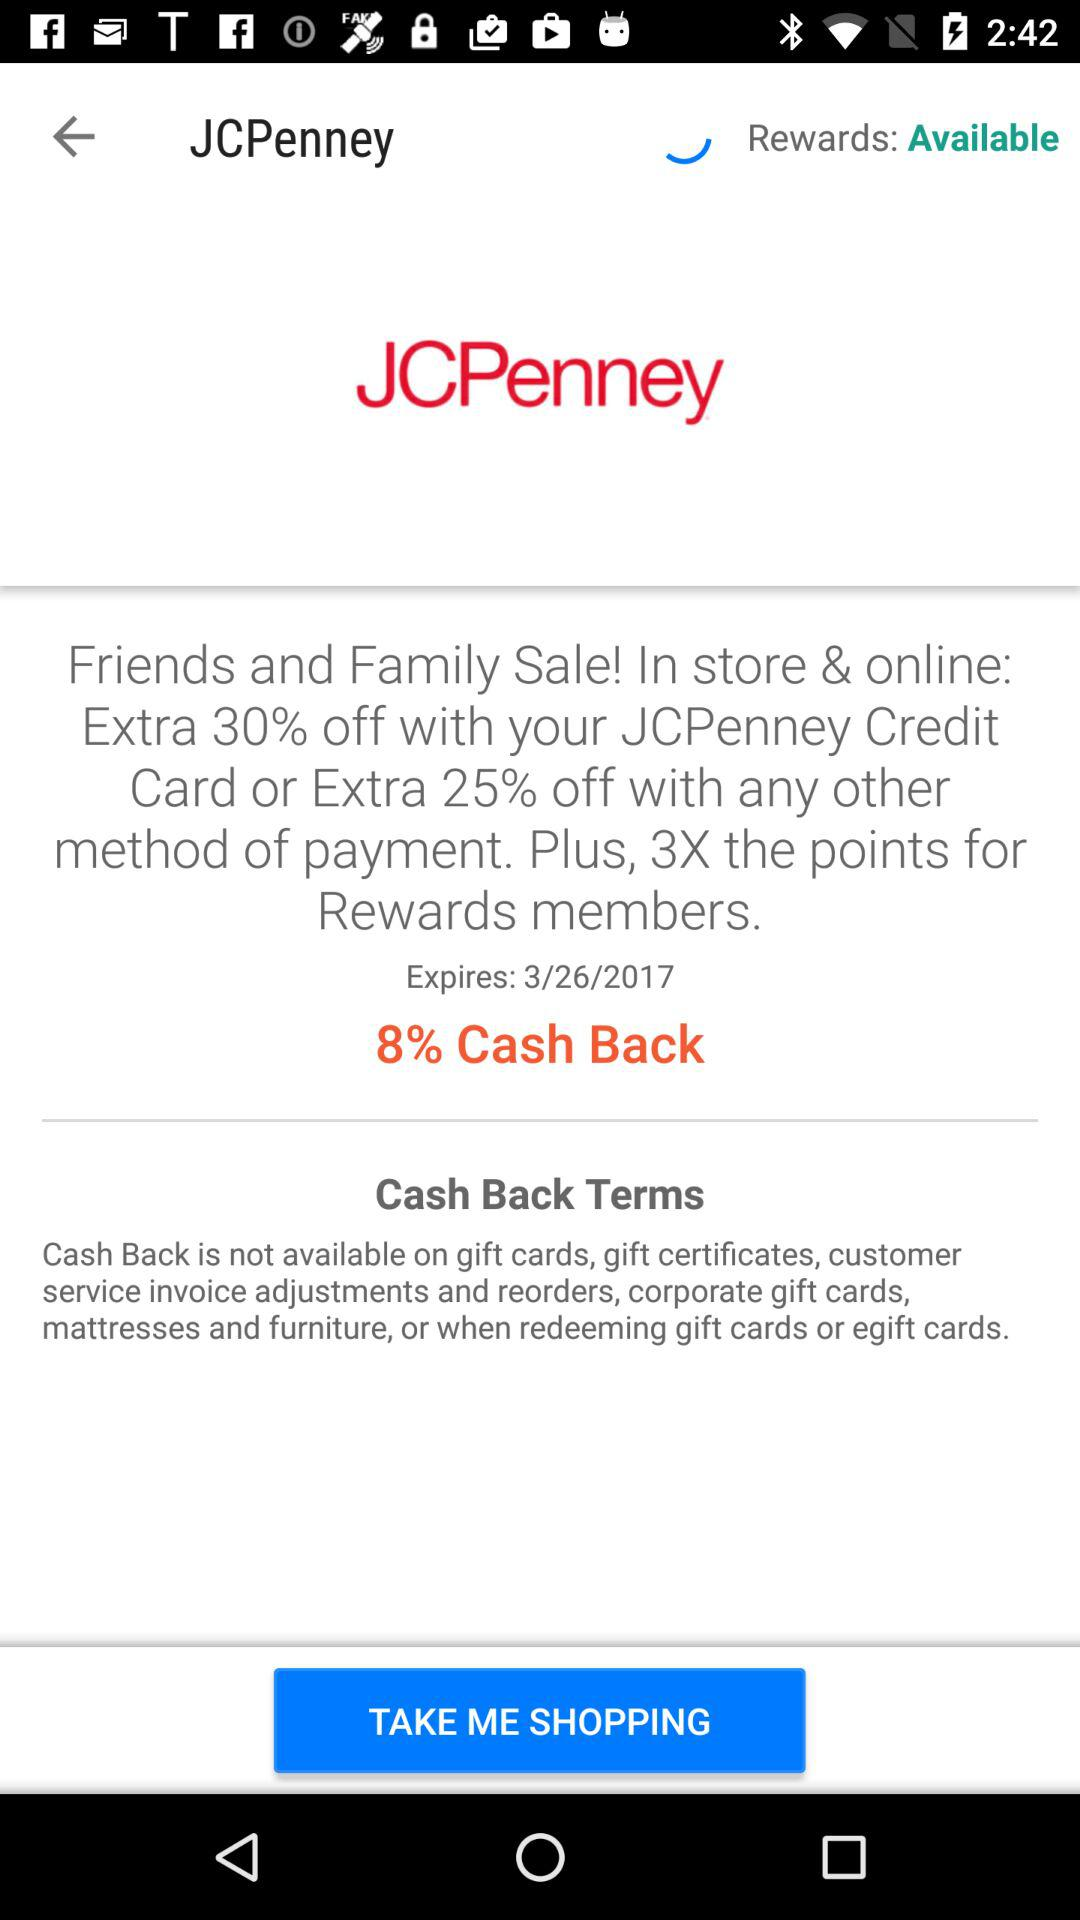When will the offer expire? The offer will expire on March 26, 2017. 